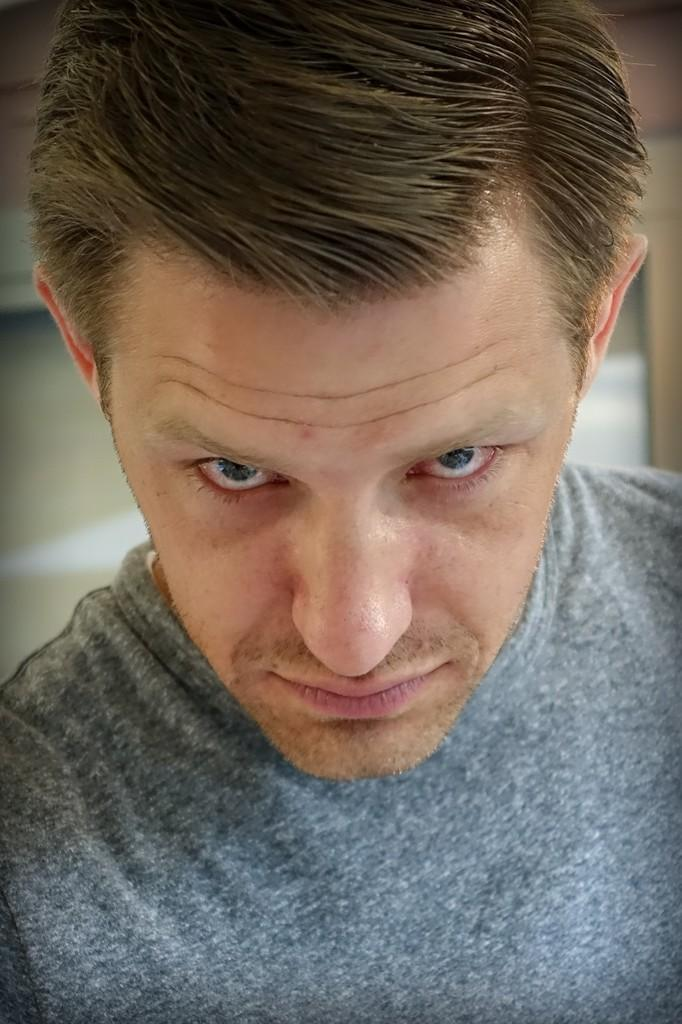What is the main subject of the image? There is a person standing in the image. Can you describe the background of the image? There appears to be a window in the background of the image. How many mice are sitting on the person's mouth in the image? There are no mice present in the image. Is there a cake visible in the image? There is no cake present in the image. 